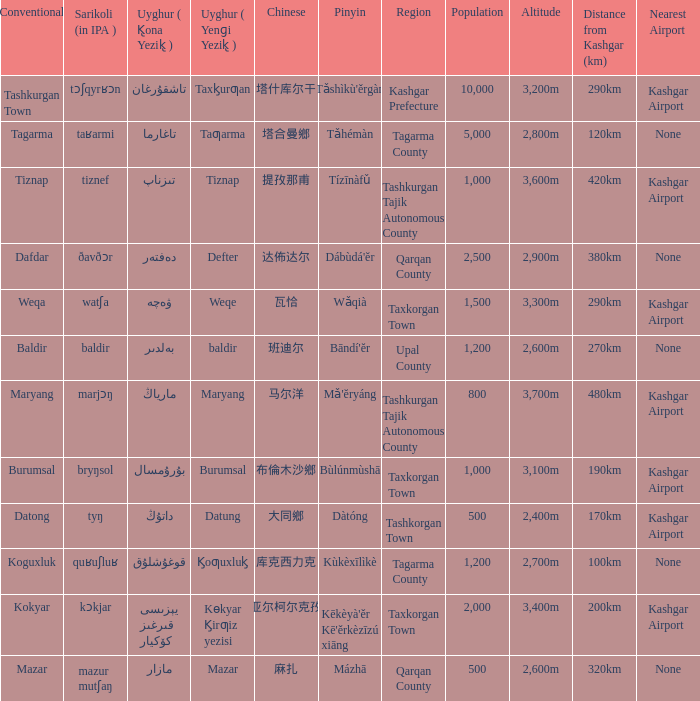Name the conventional for تاغارما Tagarma. 